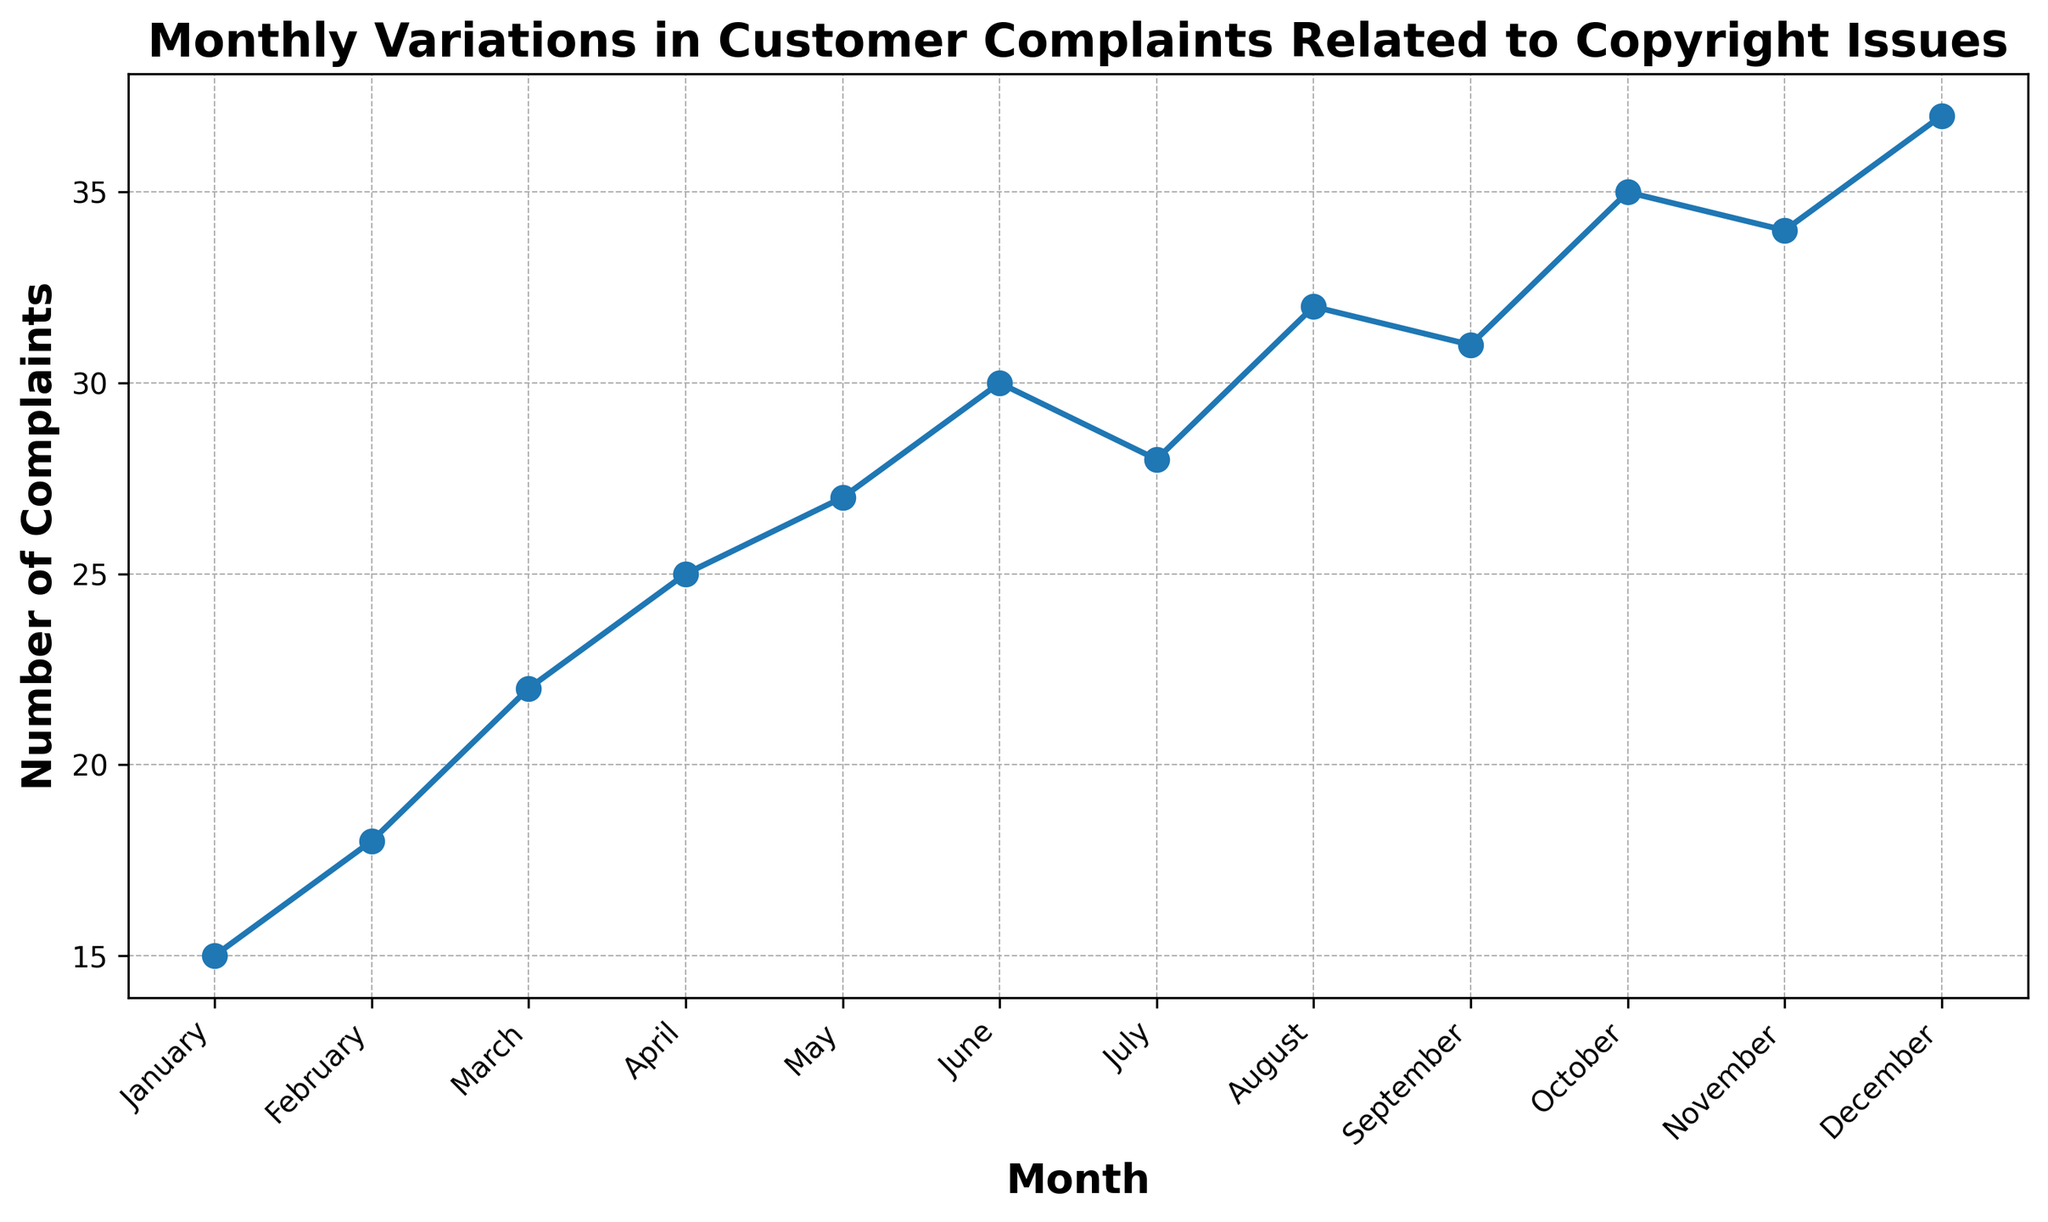What's the total number of complaints for the first half of the year? Sum the complaints from January to June: 15 + 18 + 22 + 25 + 27 + 30 = 137
Answer: 137 Which month had the highest number of complaints? The highest value in the data is 37, which corresponds to December.
Answer: December Is the number of customer complaints in April greater than in February? Compare the values: April has 25 complaints while February has 18. 25 is greater than 18.
Answer: Yes How did the number of complaints change from September to October? In September, there were 31 complaints and in October, there were 35. The change is 35 - 31 = 4.
Answer: Increased by 4 Which month had fewer complaints: July or September? Compare the values: July had 28 complaints and September had 31 complaints. 28 is less than 31.
Answer: July What's the average number of complaints for the entire year? Sum all complaints and then divide by 12: (15 + 18 + 22 + 25 + 27 + 30 + 28 + 32 + 31 + 35 + 34 + 37) / 12 = 334 / 12 = 27.83
Answer: 27.83 Which quarters have the same number of total complaints? Sum each quarter: Q1 (January-March): 15 + 18 + 22 = 55, Q2 (April-June): 25 + 27 + 30 = 82, Q3 (July-September): 28 + 32 + 31 = 91, Q4 (October-December): 35 + 34 + 37 = 106. No two quarters have the same total.
Answer: None Does the number of complaints trend upward, downward, or remain constant over the year? Observe the line chart: The number of complaints generally increases from January to December with some fluctuations.
Answer: Upward Are there any months where the number of complaints is the same? Check the values for each month. No two months have the same number of complaints.
Answer: No By how much did the number of complaints increase from January to December? Subtract the number of complaints in January from December: 37 - 15 = 22
Answer: 22 